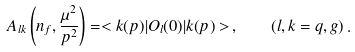Convert formula to latex. <formula><loc_0><loc_0><loc_500><loc_500>A _ { l k } \left ( n _ { f } , \frac { \mu ^ { 2 } } { p ^ { 2 } } \right ) = < k ( p ) | O _ { l } ( 0 ) | k ( p ) > \, , \quad ( l , k = q , g ) \, .</formula> 